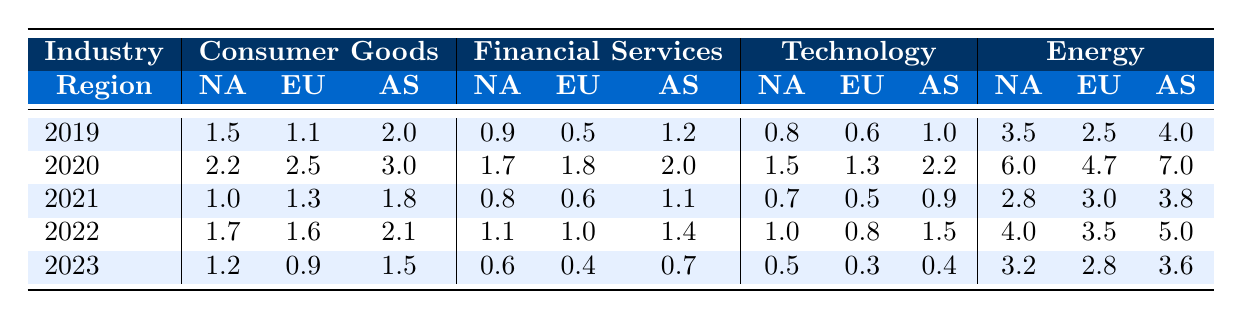What was the default rate for Financial Services in North America in 2021? Looking at the row for 2021 under the Financial Services column and North America region, the default rate is 0.8.
Answer: 0.8 What is the highest default rate for the Energy sector in Europe? The highest default rate in the Energy sector under Europe can be found by comparing the values in that column; it is 4.7, which occurred in 2020.
Answer: 4.7 What was the average default rate for the Consumer Goods sector in Asia over the five years? The default rates for Consumer Goods in Asia are 2.0, 3.0, 1.8, 2.1, and 1.5. Summing them up gives 10.4, and dividing by 5 gives an average of 2.08.
Answer: 2.08 Was the default rate for Consumer Goods in North America higher in 2020 than in 2021? The default rate for Consumer Goods in North America was 2.2 in 2020 and 1.0 in 2021; since 2.2 is greater than 1.0, the statement is true.
Answer: Yes What is the trend of default rates for Technology in Europe from 2019 to 2023? The default rates from 2019 to 2023 for Technology in Europe are 0.6, 1.3, 0.5, 0.8, and 0.3. Observing these values reveals an overall downward trend.
Answer: Downward trend What was the total default rate for Energy in North America across the years 2021 to 2023? The default rates for Energy in North America from 2021 to 2023 are 2.8, 4.0, and 3.2. Summing these gives 2.8 + 4.0 + 3.2 = 10.0.
Answer: 10.0 Which sector had the lowest default rate in Europe in 2023? In Europe in 2023, the default rates by sector are 0.9 for Consumer Goods, 0.4 for Financial Services, 0.3 for Technology, and 2.8 for Energy. The lowest rate is 0.3 in Technology.
Answer: Technology Compare the average default rates for the Consumer Goods sector across all regions for the year 2022. The default rates for Consumer Goods in 2022 are 1.7 (NA), 1.6 (EU), and 2.1 (AS). Adding these gives 5.4, and dividing by 3 gives an average of 1.8.
Answer: 1.8 What was the change in default rate for Financial Services in North America from 2019 to 2023? The default rate decreased from 0.9 in 2019 to 0.6 in 2023. The change can be calculated as 0.6 - 0.9 = -0.3.
Answer: Decreased by 0.3 Is the default rate for Energy in Asia consistently higher than in North America from 2019 to 2023? The default rates for Energy in Asia are 4.0, 7.0, 3.8, 5.0, and 3.6 and for North America are 3.5, 6.0, 2.8, 4.0, and 3.2. In 2019, 2020, and 2022, Asia is higher; not in 2021 and 2023, so it is not consistent.
Answer: No, not consistent What is the difference in the average default rate between Consumer Goods and Energy sectors in North America over the five-year period? The average for Consumer Goods in North America is (1.5 + 2.2 + 1.0 + 1.7 + 1.2)/5 = 1.53. The average for Energy is (3.5 + 6.0 + 2.8 + 4.0 + 3.2)/5 = 3.72. The difference is 3.72 - 1.53 = 2.19.
Answer: 2.19 